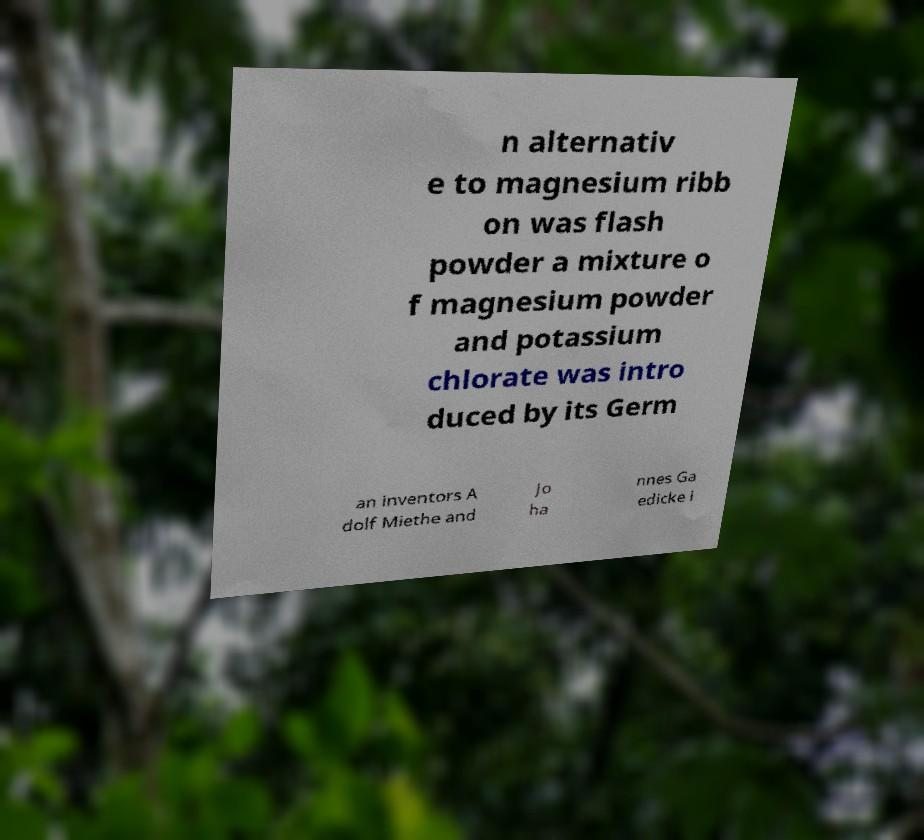Please read and relay the text visible in this image. What does it say? n alternativ e to magnesium ribb on was flash powder a mixture o f magnesium powder and potassium chlorate was intro duced by its Germ an inventors A dolf Miethe and Jo ha nnes Ga edicke i 